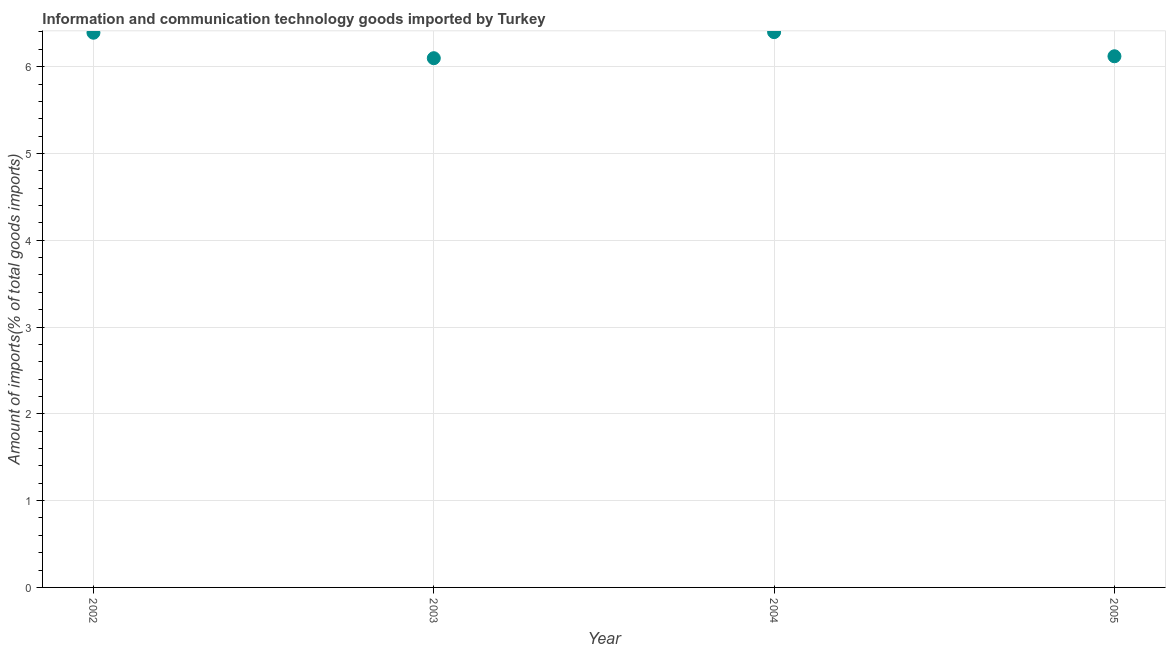What is the amount of ict goods imports in 2004?
Provide a succinct answer. 6.4. Across all years, what is the maximum amount of ict goods imports?
Your answer should be very brief. 6.4. Across all years, what is the minimum amount of ict goods imports?
Your answer should be compact. 6.1. In which year was the amount of ict goods imports minimum?
Offer a very short reply. 2003. What is the sum of the amount of ict goods imports?
Your answer should be compact. 25.01. What is the difference between the amount of ict goods imports in 2002 and 2003?
Your answer should be compact. 0.29. What is the average amount of ict goods imports per year?
Provide a short and direct response. 6.25. What is the median amount of ict goods imports?
Your answer should be compact. 6.26. Do a majority of the years between 2005 and 2002 (inclusive) have amount of ict goods imports greater than 5.2 %?
Keep it short and to the point. Yes. What is the ratio of the amount of ict goods imports in 2003 to that in 2005?
Your response must be concise. 1. What is the difference between the highest and the second highest amount of ict goods imports?
Offer a very short reply. 0.01. Is the sum of the amount of ict goods imports in 2002 and 2004 greater than the maximum amount of ict goods imports across all years?
Ensure brevity in your answer.  Yes. What is the difference between the highest and the lowest amount of ict goods imports?
Provide a short and direct response. 0.3. In how many years, is the amount of ict goods imports greater than the average amount of ict goods imports taken over all years?
Your response must be concise. 2. Does the amount of ict goods imports monotonically increase over the years?
Keep it short and to the point. No. How many dotlines are there?
Offer a terse response. 1. How many years are there in the graph?
Offer a very short reply. 4. What is the difference between two consecutive major ticks on the Y-axis?
Provide a succinct answer. 1. Does the graph contain grids?
Provide a succinct answer. Yes. What is the title of the graph?
Keep it short and to the point. Information and communication technology goods imported by Turkey. What is the label or title of the X-axis?
Provide a succinct answer. Year. What is the label or title of the Y-axis?
Your answer should be compact. Amount of imports(% of total goods imports). What is the Amount of imports(% of total goods imports) in 2002?
Make the answer very short. 6.39. What is the Amount of imports(% of total goods imports) in 2003?
Your answer should be very brief. 6.1. What is the Amount of imports(% of total goods imports) in 2004?
Make the answer very short. 6.4. What is the Amount of imports(% of total goods imports) in 2005?
Your answer should be very brief. 6.12. What is the difference between the Amount of imports(% of total goods imports) in 2002 and 2003?
Offer a terse response. 0.29. What is the difference between the Amount of imports(% of total goods imports) in 2002 and 2004?
Offer a very short reply. -0.01. What is the difference between the Amount of imports(% of total goods imports) in 2002 and 2005?
Keep it short and to the point. 0.27. What is the difference between the Amount of imports(% of total goods imports) in 2003 and 2004?
Provide a short and direct response. -0.3. What is the difference between the Amount of imports(% of total goods imports) in 2003 and 2005?
Provide a short and direct response. -0.02. What is the difference between the Amount of imports(% of total goods imports) in 2004 and 2005?
Provide a succinct answer. 0.28. What is the ratio of the Amount of imports(% of total goods imports) in 2002 to that in 2003?
Ensure brevity in your answer.  1.05. What is the ratio of the Amount of imports(% of total goods imports) in 2002 to that in 2004?
Provide a succinct answer. 1. What is the ratio of the Amount of imports(% of total goods imports) in 2002 to that in 2005?
Offer a very short reply. 1.04. What is the ratio of the Amount of imports(% of total goods imports) in 2003 to that in 2004?
Offer a very short reply. 0.95. What is the ratio of the Amount of imports(% of total goods imports) in 2003 to that in 2005?
Your answer should be compact. 1. What is the ratio of the Amount of imports(% of total goods imports) in 2004 to that in 2005?
Give a very brief answer. 1.04. 